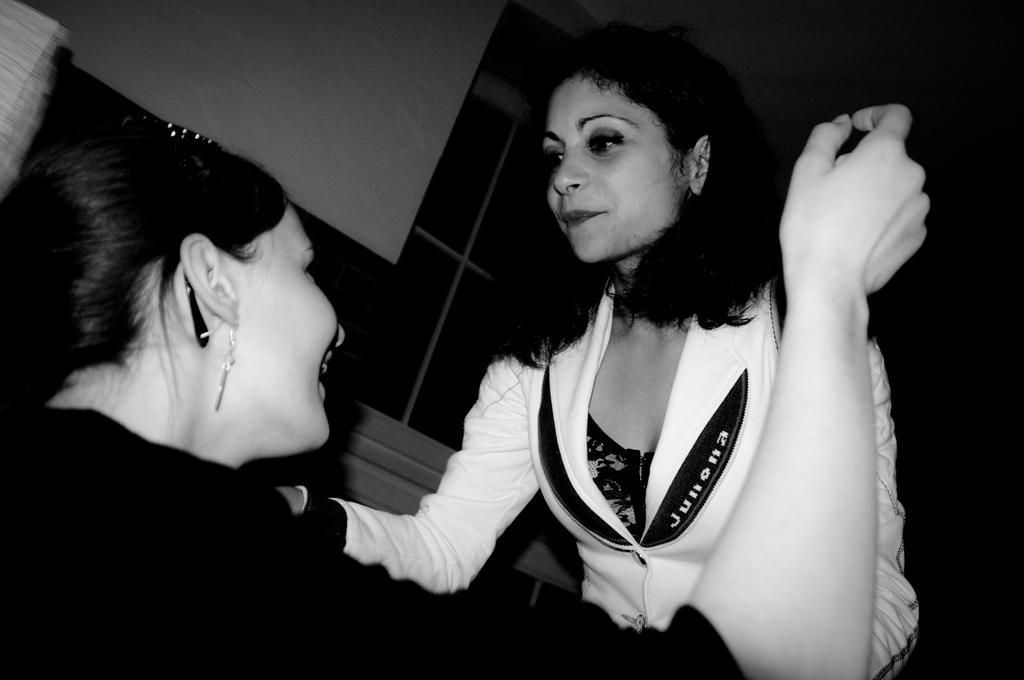Please provide a concise description of this image. In this image there is one person at left side of this image is wearing black color dress and the person at right side is wearing white color dress. There is a wall in the background. 